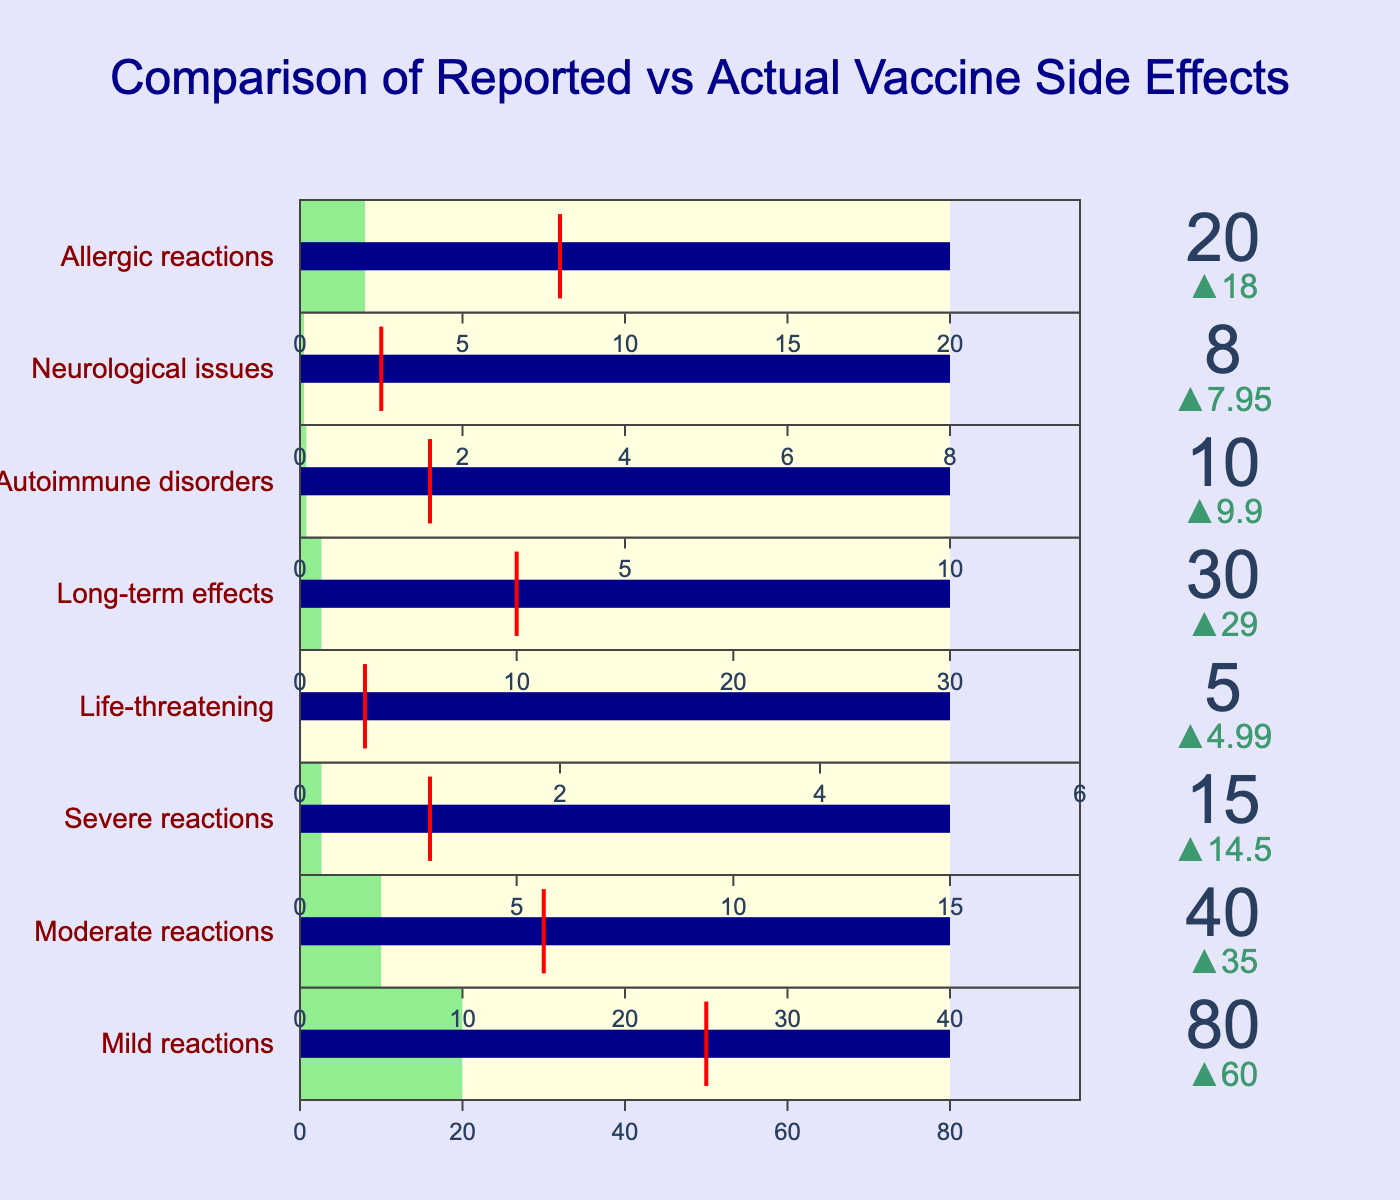How many categories are displayed in the chart? There are eight categories in the dataset, and each category corresponds to a row in the bullet chart.
Answer: 8 What color represents the actual occurrences of side effects in the chart? In the bullet chart, the steps of the gauge that represent the actual occurrences are highlighted in light green.
Answer: Light green Which category has the highest reported value? The "Mild reactions" category has the highest reported value at 80. This can be observed by comparing the values shown in each category's bullet chart.
Answer: Mild reactions What is the difference between the reported and actual values for severe reactions? The reported value for severe reactions is 15, and the actual value is 0.5. The difference is calculated as 15 - 0.5 = 14.5.
Answer: 14.5 What is the target value for long-term effects, and how does it compare to the reported value? The target value for long-term effects is 10, whereas the reported value is 30. The reported value is 20 units higher than the target.
Answer: 10, reported is 20 higher Which category shows the smallest difference between reported and actual occurrences? The smallest difference between reported and actual occurrences is found in the "Life-threatening" category, with a difference of 5 - 0.01 = 4.99.
Answer: Life-threatening What can be inferred about the severity of side effects from the color of the bar in the bullet charts? The bar color is dark blue, indicating that the reported values are usually higher than both the actual occurrences (light green) and the target (red line). This discrepancy may suggest over-reporting or differing perceptions of side effect severity.
Answer: Over-reporting or differing perceptions How do the actual occurrences of long-term effects compare to neurological issues? The actual occurrences for long-term effects are 1, while for neurological issues, it's 0.05. The long-term effects have a higher actual occurrence than neurological issues.
Answer: Long-term effects higher Comparing mild reactions to moderate reactions, which category exceeds its target more significantly? Mild reactions have a reported value of 80 and a target of 50, exceeding by 30. Moderate reactions have a reported value of 40 and a target of 15, exceeding by 25. Mild reactions exceed their target more significantly by 5 units.
Answer: Mild reactions What insight can be gained by comparing the reported and actual values in terms of public perception of vaccine side effects? Comparing the reported and actual values highlights a substantial overestimation of side effect occurrences across all categories. This suggests that public perception considers vaccine side effects to be more common than they actually are, potentially influencing attitudes towards vaccination.
Answer: Overestimation influences attitudes 